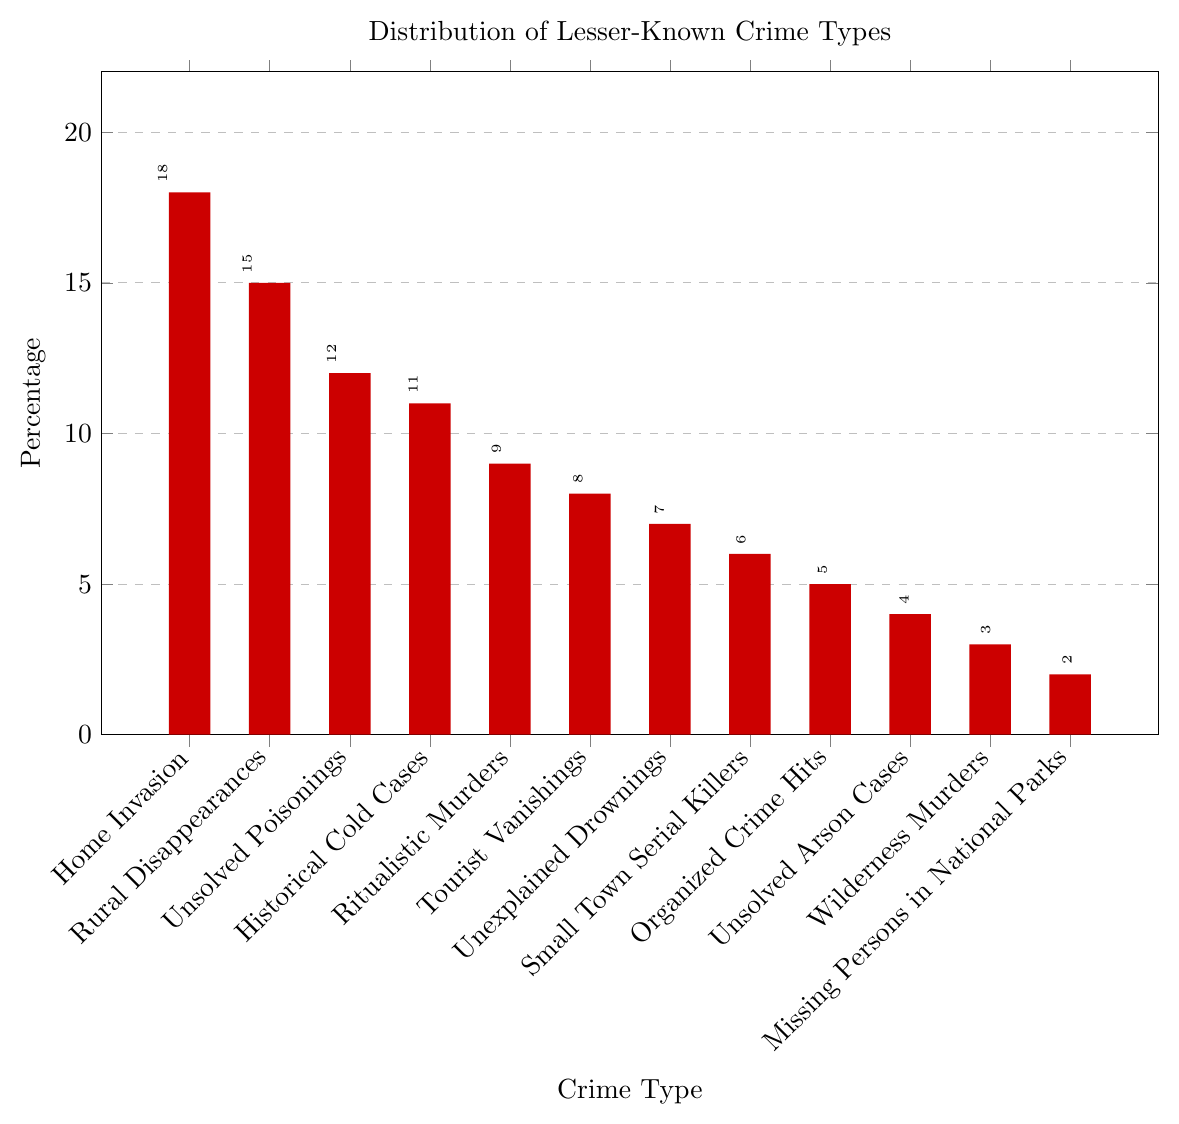What crime type has the highest percentage? The chart shows various crime types and their corresponding percentages. The highest bar represents the crime type with the maximum percentage. In this case, the "Home Invasion" bar is the tallest.
Answer: Home Invasion Which crime type has the lowest percentage? Examine the chart for the bar with the smallest height. The shortest bar corresponds to "Missing Persons in National Parks," indicating it has the lowest percentage.
Answer: Missing Persons in National Parks What is the combined percentage of Rural Disappearances, Unsolved Poisonings, and Historical Cold Cases? Add the percentages of the specified crime types: Rural Disappearances (15) + Unsolved Poisonings (12) + Historical Cold Cases (11) = 38.
Answer: 38 How does the percentage of Ritualistic Murders compare to that of Tourist Vanishings? Compare the heights of the bars labeled "Ritualistic Murders" and "Tourist Vanishings." Ritualistic Murders has a bar height of 9%, while Tourist Vanishings has a bar height of 8%.
Answer: Ritualistic Murders is higher Which crime type(s) have a percentage greater than or equal to 10%? Look for bars with a height of 10% or more. The crime types meeting this criterion are "Home Invasion" (18%), "Rural Disappearances" (15%), "Unsolved Poisonings" (12%), and "Historical Cold Cases" (11%).
Answer: Home Invasion, Rural Disappearances, Unsolved Poisonings, Historical Cold Cases If you sum the percentages of Tourist Vanishings, Unexplained Drownings, and Small Town Serial Killers, what is the total? Add the percentages of Tourist Vanishings (8) + Unexplained Drownings (7) + Small Town Serial Killers (6) = 21.
Answer: 21 Is the percentage of Unsolved Arson Cases more or less than Organized Crime Hits? By how much? Compare the heights of the bars for Unsolved Arson Cases (4%) and Organized Crime Hits (5%). The difference is 5 - 4 = 1.
Answer: Less by 1 List the crime types with percentages less than 5%. Examine the chart for bars with a height less than 5%. The relevant crime types are "Wilderness Murders" (3%) and "Missing Persons in National Parks" (2%).
Answer: Wilderness Murders, Missing Persons in National Parks How many crime types have a percentage between 5% and 10% inclusive? Find the number of bars with heights in the specified range. The relevant crime types are "Ritualistic Murders" (9%), "Tourist Vanishings" (8%), "Unexplained Drownings" (7%), "Small Town Serial Killers" (6%), and "Organized Crime Hits" (5%). There are 5 crime types in this range.
Answer: 5 